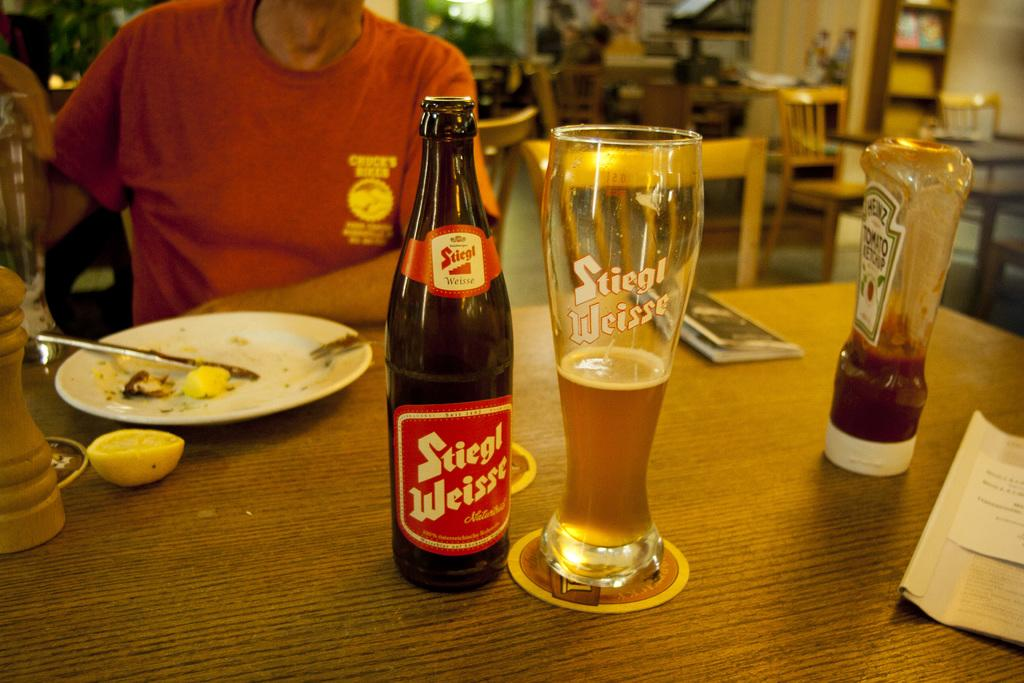<image>
Summarize the visual content of the image. a table has a used plate and a half drank glass of Stiegl Weisse beside it 